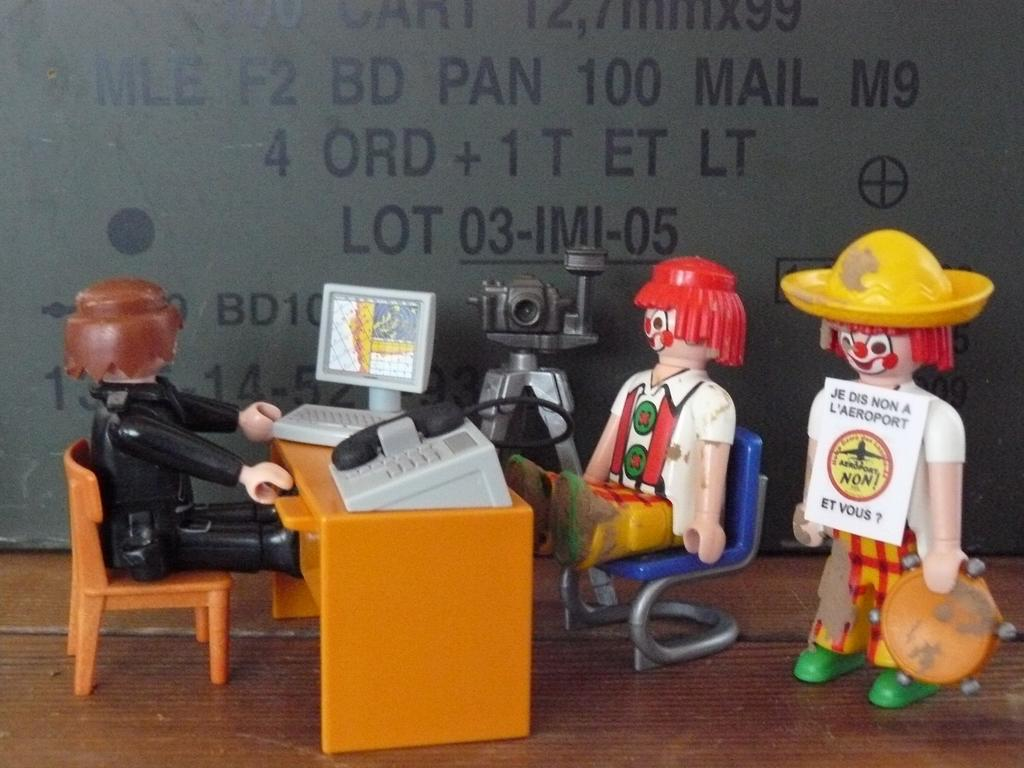What objects are sitting on a chair in the image? There are toys sitting on a chair in the image. What is the position of one of the toys in the image? There is a toy standing in the image. What furniture is present in the image? There is a table in the image. What electronic devices are visible in the image? There is a mobile, a monitor, a keyboard, and a camera in the image. What type of rock is featured in the image? There is no rock present in the image; it features toys, a table, and electronic devices. What country is depicted in the image? The image does not depict any country; it is a still life of toys, a table, and electronic devices. 